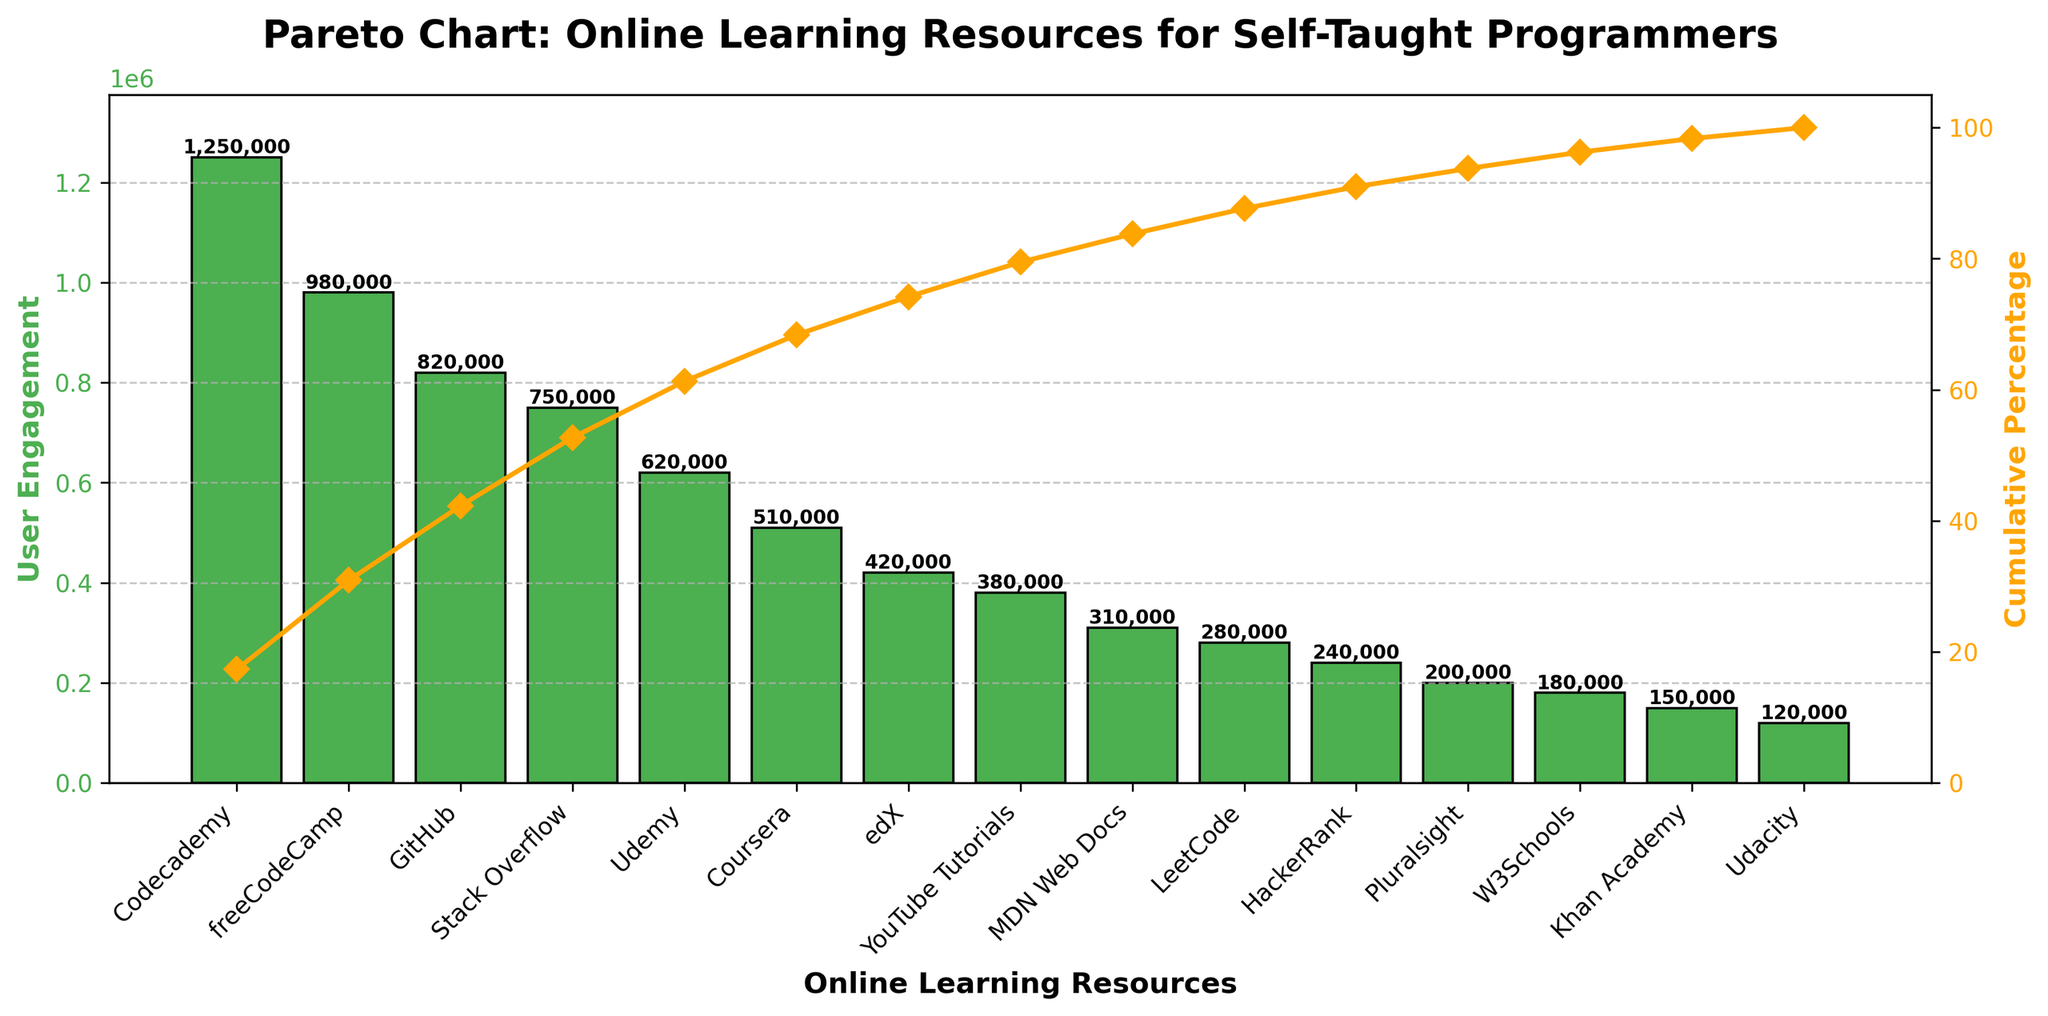How many user engagement points does Codecademy have? According to the figure, Codecademy has a bar representing user engagement that reaches up to 1,250,000 points. This information can be directly read from the height of the first bar.
Answer: 1,250,000 Which two resources together make up the most substantial user engagement? The two largest bars in the figure represent the resources Codecademy and freeCodeCamp. By analyzing their heights, we see Codecademy has 1,250,000 points and freeCodeCamp has 980,000 points. Adding these, we get 1,250,000 + 980,000 = 2,230,000.
Answer: Codecademy and freeCodeCamp What is the cumulative percentage of user engagement for Codecademy and freeCodeCamp combined? The cumulative percentage is shown as a line graph. At the point where freeCodeCamp is labeled, the cumulative percentage is around 51.8%. This includes the cumulative effect of both Codecademy and freeCodeCamp.
Answer: 51.8% Which resource shows a user engagement of 620,000? From the figure, the bar for Udemy reaches up to 620,000 points, indicating that Udemy is the resource with this user engagement level.
Answer: Udemy Is the user engagement for the top three resources greater than that of the bottom seven combined? First sum up the top three: Codecademy (1,250,000), freeCodeCamp (980,000), and GitHub (820,000). This gives 1,250,000 + 980,000 + 820,000 = 3,050,000. Now sum up the bottom seven: HackerRank (240,000), Pluralsight (200,000), W3Schools (180,000), Khan Academy (150,000), Udacity (120,000). This gives 420,000 + 380,000 + 310,000 + 280,000 + 1,630,000. Comparing, 3,050,000 is greater.
Answer: Yes What are the user engagement values for resources that have less than 300,000 points? From the figure, resources with less than 300,000 points are LeetCode (280,000), HackerRank (240,000), Pluralsight (200,000), W3Schools (180,000), Khan Academy (150,000), and Udacity (120,000).
Answer: LeetCode, HackerRank, Pluralsight, W3Schools, Khan Academy, Udacity By what percentage does GitHub contribute to the total user engagement? First, find GitHub's user engagement, which is 820,000 points. The total user engagement is obtained by summing all values: 1250000 + 980000 + 820000 + 750000 + 620000 + 510000 + 420000 + 380000 + 310000 + 280000 + 240000 + 200000 + 180000 + 150000 + 120000 = 7,280,000. The percentage contribution of GitHub is (820,000 / 7,280,000) * 100 ≈ 11.26%.
Answer: 11.26% Among the listed resources, which one has the lowest user engagement and how is this represented in the figure? According to the figure, Udacity has the lowest user engagement with 120,000 points. This is represented by the shortest bar in the Pareto chart.
Answer: Udacity, 120,000 